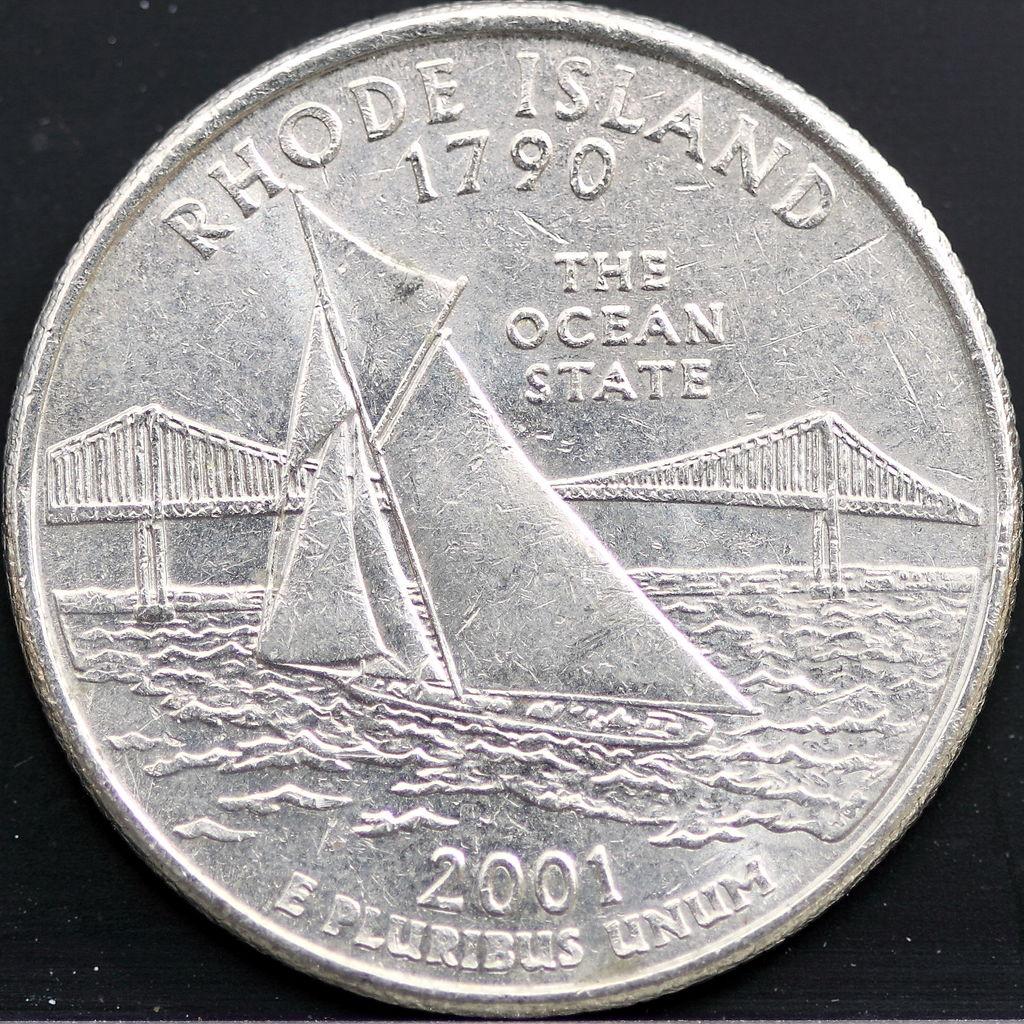What is the bottom year of this coin?
Give a very brief answer. 2001. What state is represented by this coin?
Give a very brief answer. Rhode island. 